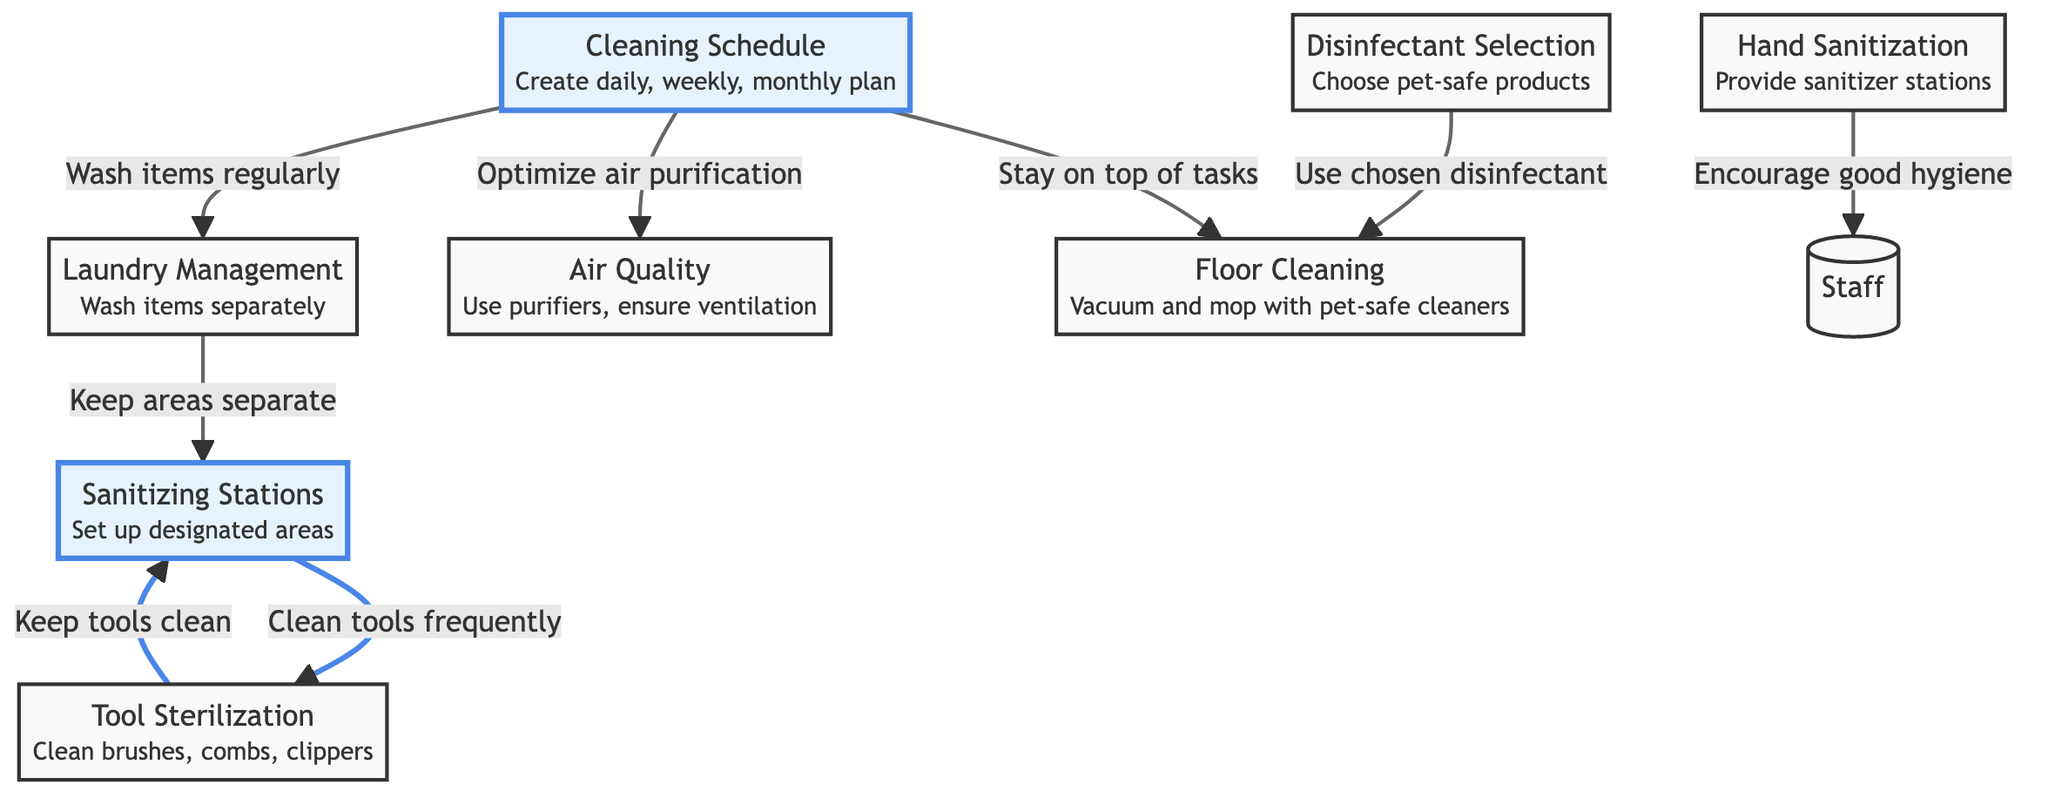What is the first node in the diagram? The first node is "Sanitizing Stations" which is the starting point of the flowchart. This node focuses on setting up designated areas for sanitizing.
Answer: Sanitizing Stations How many main nodes are highlighted in the diagram? There are three highlighted nodes: "Sanitizing Stations," "Cleaning Schedule," and "Tool Sterilization." These nodes are visually emphasized to indicate their importance in the sanitization process.
Answer: 3 What does the "Cleaning Schedule" node lead to? The "Cleaning Schedule" node leads to three other nodes: "Laundry Management," "Floor Cleaning," and "Air Quality." It suggests that maintaining a schedule affects multiple aspects of the grooming salon's cleanliness.
Answer: Laundry Management, Floor Cleaning, Air Quality What relationship does "Tool Sterilization" have with "Sanitizing Stations"? The relationship is that "Tool Sterilization" leads to "Sanitizing Stations," indicating that keeping tools clean contributes to maintaining sanitary conditions in designated areas.
Answer: Keeps tools clean Which node is related to air purification? The "Cleaning Schedule" node is related to air purification as it indicates the need to optimize air quality, highlighting that scheduling regular cleaning helps maintain a healthy environment.
Answer: Cleaning Schedule What is the purpose of "Hand Sanitization" in the diagram? The purpose of "Hand Sanitization" is to encourage good hygiene among the staff by providing sanitizer stations, which is vital for preventing the spread of germs within the salon.
Answer: Encourage good hygiene What does the "Laundry Management" node emphasize regarding cleaning items? It emphasizes the need to wash items separately to prevent contamination, stressing the importance of keeping different cleaning items segregated during laundry.
Answer: Wash items separately How does "Disinfectant Selection" influence "Floor Cleaning"? "Disinfectant Selection" influences "Floor Cleaning" by indicating that the chosen pet-safe disinfectants should be used during floor cleaning, reinforcing safe practices for both pets and staff.
Answer: Use chosen disinfectant What is the purpose of the arrows in the diagram? The arrows indicate relationships between nodes, showing the flow of processes and how different aspects of salon sanitation affect one another.
Answer: Indicate relationships 